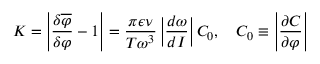<formula> <loc_0><loc_0><loc_500><loc_500>K = \left | \frac { \delta \overline { \varphi } } { \delta \varphi } - 1 \right | = \frac { \pi \epsilon \nu } { T \omega ^ { 3 } } \left | \frac { d \omega } { d I } \right | C _ { 0 } , \quad C _ { 0 } \equiv \left | \frac { \partial C } { \partial \varphi } \right |</formula> 